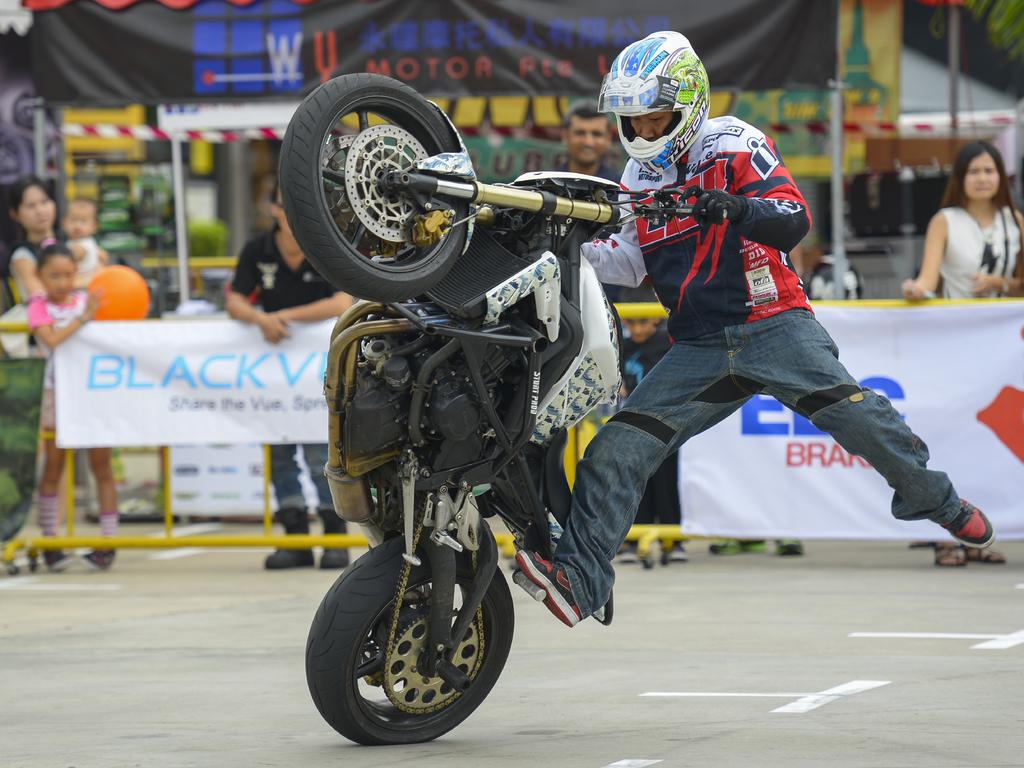What is the man in the image doing? The man is riding a bike in the image. What can be seen beneath the man and the bike? The ground is visible in the image. What is happening in the background of the image? There are persons standing on the road and advertisements visible in the background of the image. What type of structures can be seen in the background of the image? Road dividers and poles are visible in the background of the image. What type of cap is the man wearing while riding the bike in the image? The man is not wearing a cap in the image; he is simply riding the bike. Can you tell me how much the receipt costs for the bike in the image? There is no receipt present in the image, so it is not possible to determine its cost. 